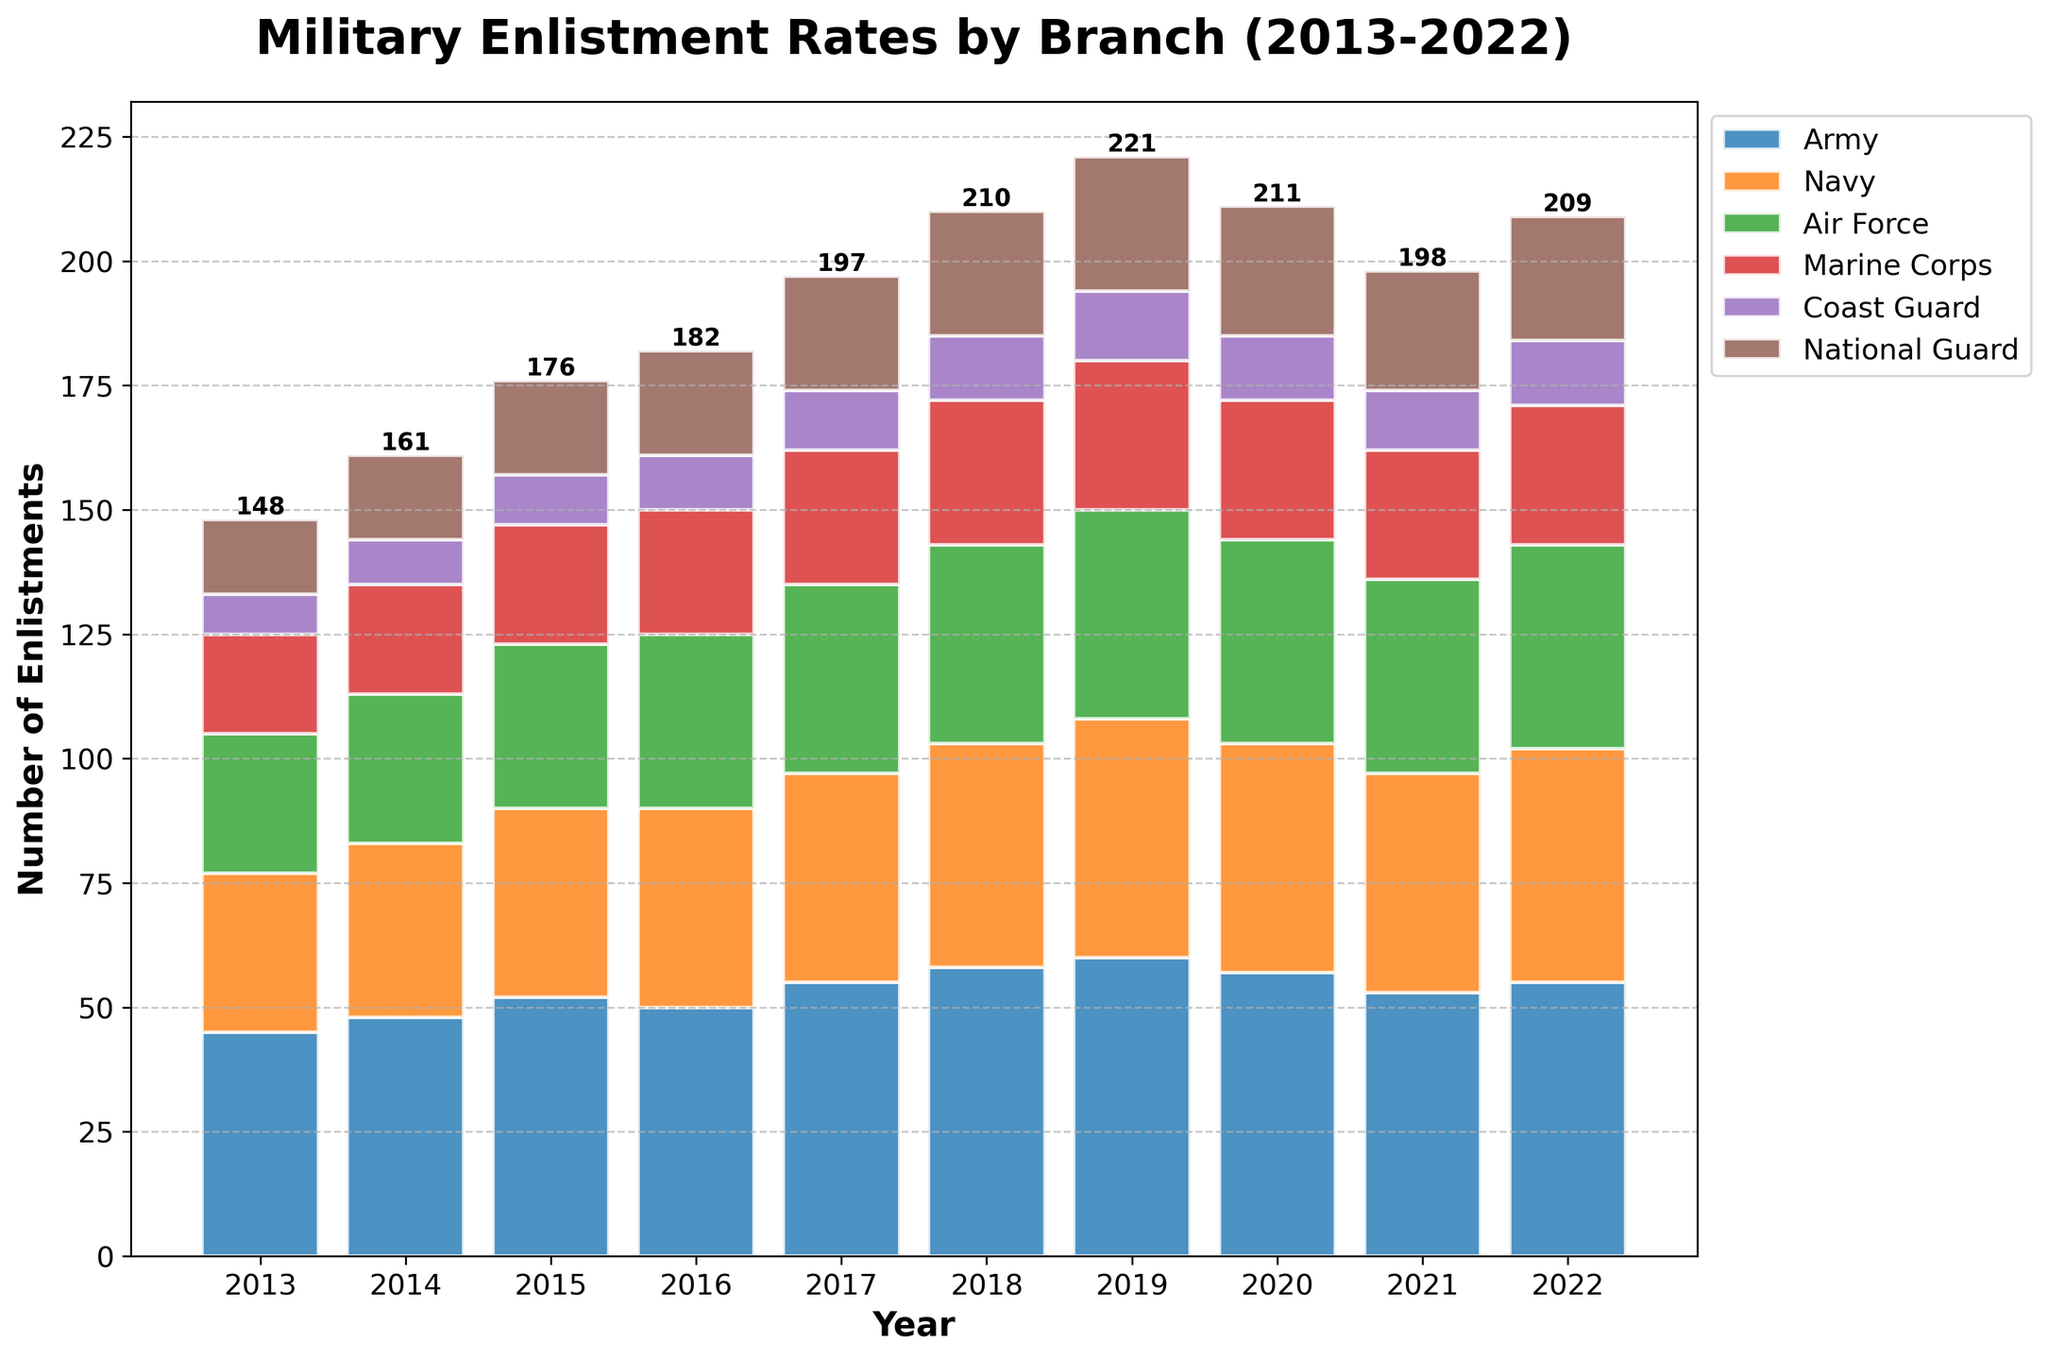Which branch had the highest enlistment rate in 2022? Look at the height of the bars for each branch in the year 2022. The Army has the tallest bar.
Answer: Army How has the Marine Corps' enlistment rate changed from 2013 to 2022? Compare the height of the Marine Corps bars from 2013 (20) to 2022 (28). The difference is 28 - 20 = 8.
Answer: Increased by 8 By how much did the National Guard's enlistment rate increase from 2013 to 2018? Look at the National Guard's enlistment rates in 2013 (15) and 2018 (25). The difference is 25 - 15 = 10.
Answer: 10 Which two branches had the closest enlistment rates in 2021? Compare the height of the bars for 2021. The Air Force (39) and Navy (44) bars are closest.
Answer: Air Force and Navy What is the total number of enlistments in 2020? Add the heights of all the bars in 2020. Army (57) + Navy (46) + Air Force (41) + Marine Corps (28) + Coast Guard (13) + National Guard (26) = 211.
Answer: 211 Which branch showed the most consistent growth over the decade? Analyze the trend of the bars for each branch. The Air Force shows a steady increase each year.
Answer: Air Force In which year did the Army have its highest enlistment rate? Observe the heights of the bars for the Army for all years. The highest bar is in 2019 (60).
Answer: 2019 Did the Coast Guard's enlistment rate ever decrease over the past decade? Check the height of the bars for the Coast Guard over the years. There is no decrease from one year to the next.
Answer: No 